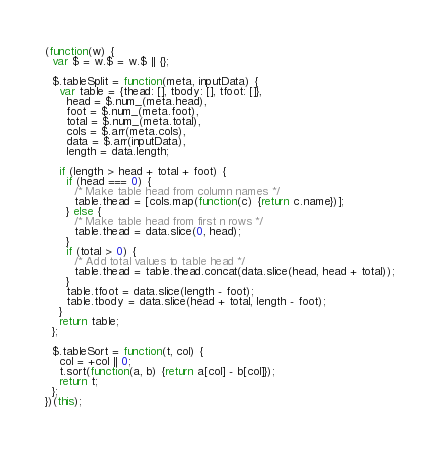Convert code to text. <code><loc_0><loc_0><loc_500><loc_500><_JavaScript_>(function(w) {
  var $ = w.$ = w.$ || {};

  $.tableSplit = function(meta, inputData) {
    var table = {thead: [], tbody: [], tfoot: []},
      head = $.num_(meta.head),
      foot = $.num_(meta.foot),
      total = $.num_(meta.total),
      cols = $.arr(meta.cols),
      data = $.arr(inputData),
      length = data.length;

    if (length > head + total + foot) {
      if (head === 0) {
        /* Make table head from column names */
        table.thead = [cols.map(function(c) {return c.name})];
      } else {
        /* Make table head from first n rows */
        table.thead = data.slice(0, head);
      }
      if (total > 0) {
        /* Add total values to table head */
        table.thead = table.thead.concat(data.slice(head, head + total));
      }
      table.tfoot = data.slice(length - foot);
      table.tbody = data.slice(head + total, length - foot);
    }
    return table;
  };

  $.tableSort = function(t, col) {
    col = +col || 0;
    t.sort(function(a, b) {return a[col] - b[col]});
    return t;
  };
})(this);
</code> 